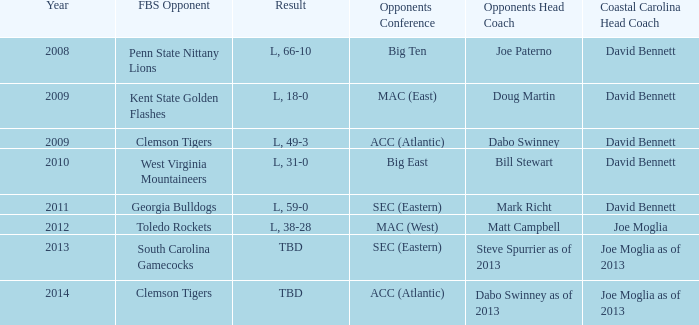Who was the coastal Carolina head coach in 2013? Joe Moglia as of 2013. 